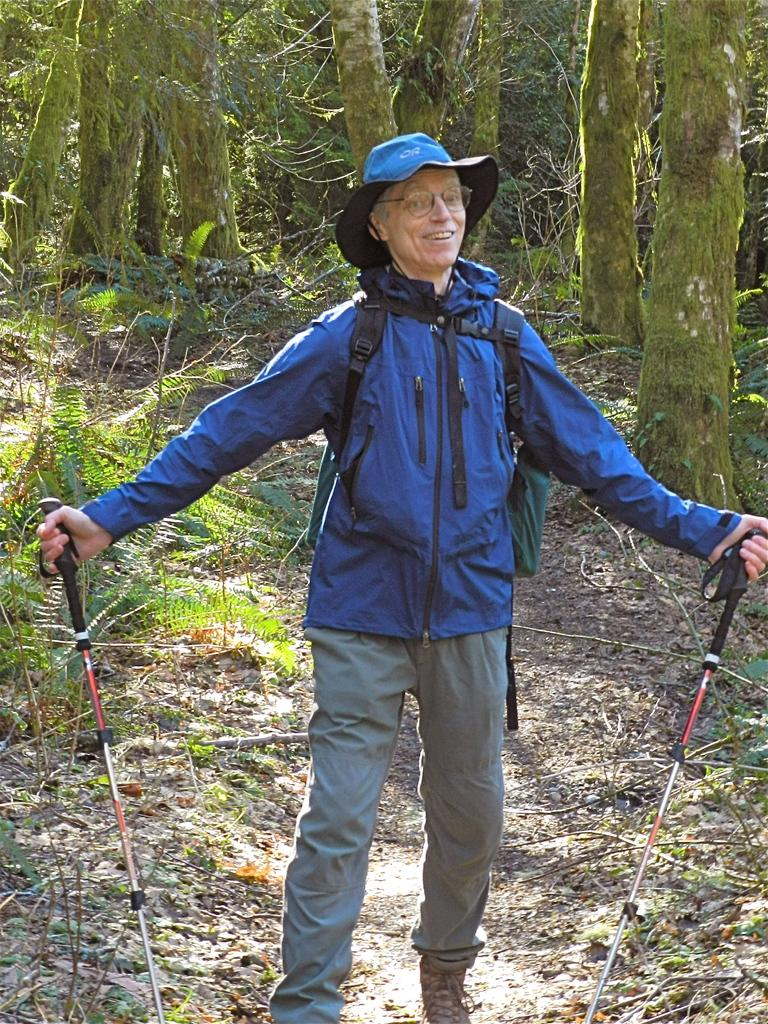What is the main subject of the image? There is a man standing in the center of the image. What is the man holding in his hand? The man is holding a walking stick in his hand. What can be seen in the background of the image? There are trees in the background of the image. What type of ground is visible at the bottom of the image? Grass is present at the bottom of the image. Can you see a ship sailing in the background of the image? No, there is no ship present in the image; only trees can be seen in the background. 